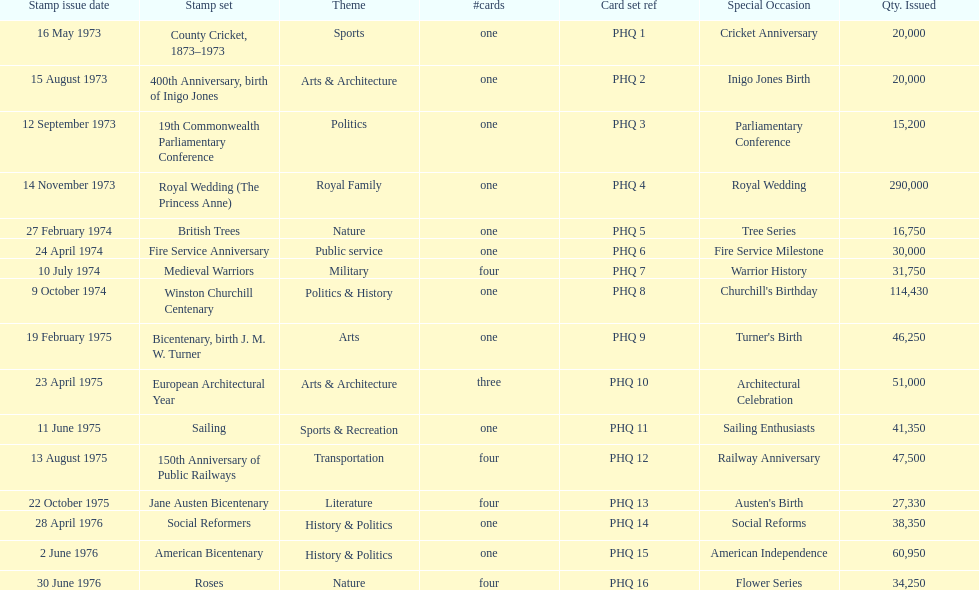Which was the only stamp set to have more than 200,000 issued? Royal Wedding (The Princess Anne). 